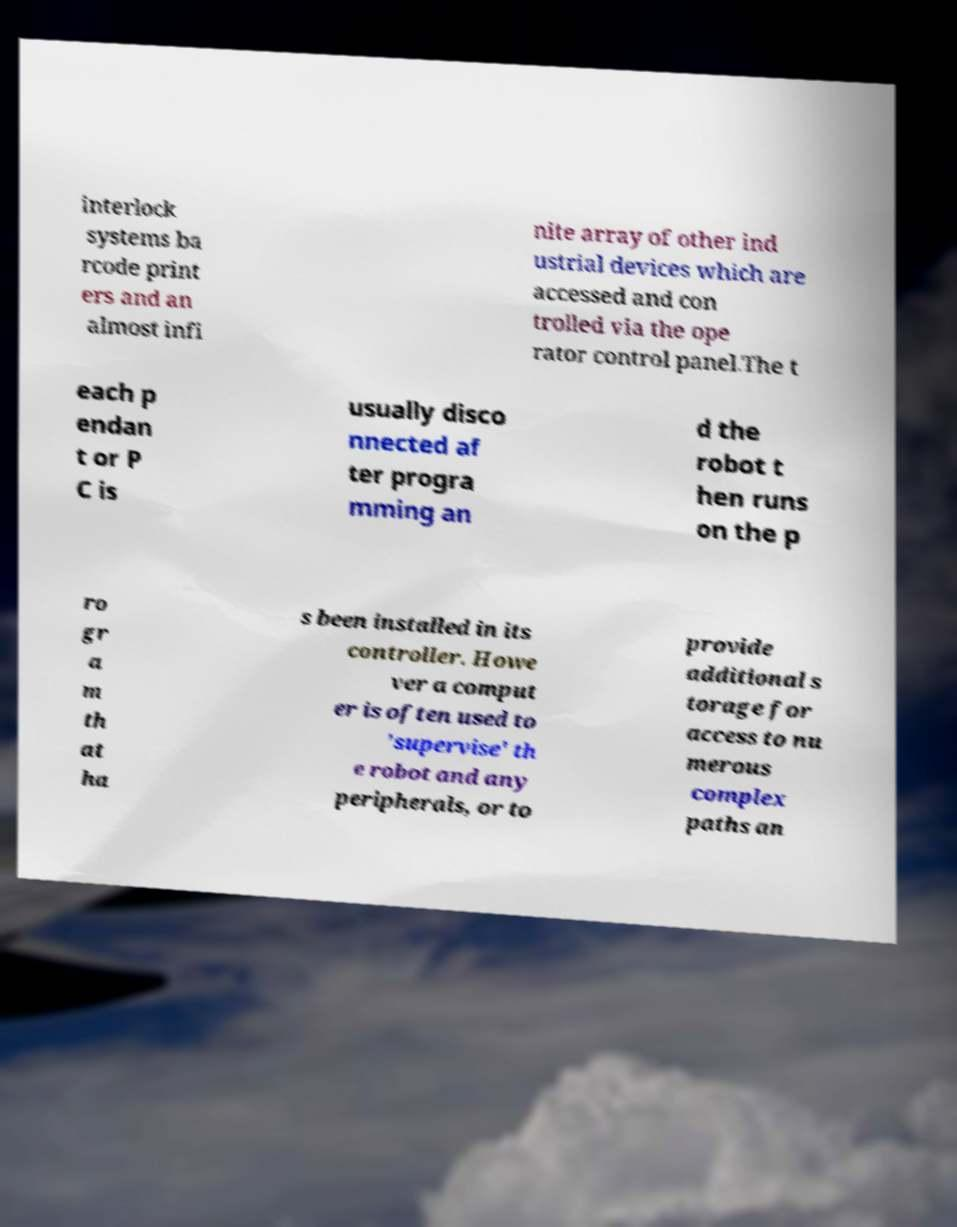Please identify and transcribe the text found in this image. interlock systems ba rcode print ers and an almost infi nite array of other ind ustrial devices which are accessed and con trolled via the ope rator control panel.The t each p endan t or P C is usually disco nnected af ter progra mming an d the robot t hen runs on the p ro gr a m th at ha s been installed in its controller. Howe ver a comput er is often used to 'supervise' th e robot and any peripherals, or to provide additional s torage for access to nu merous complex paths an 